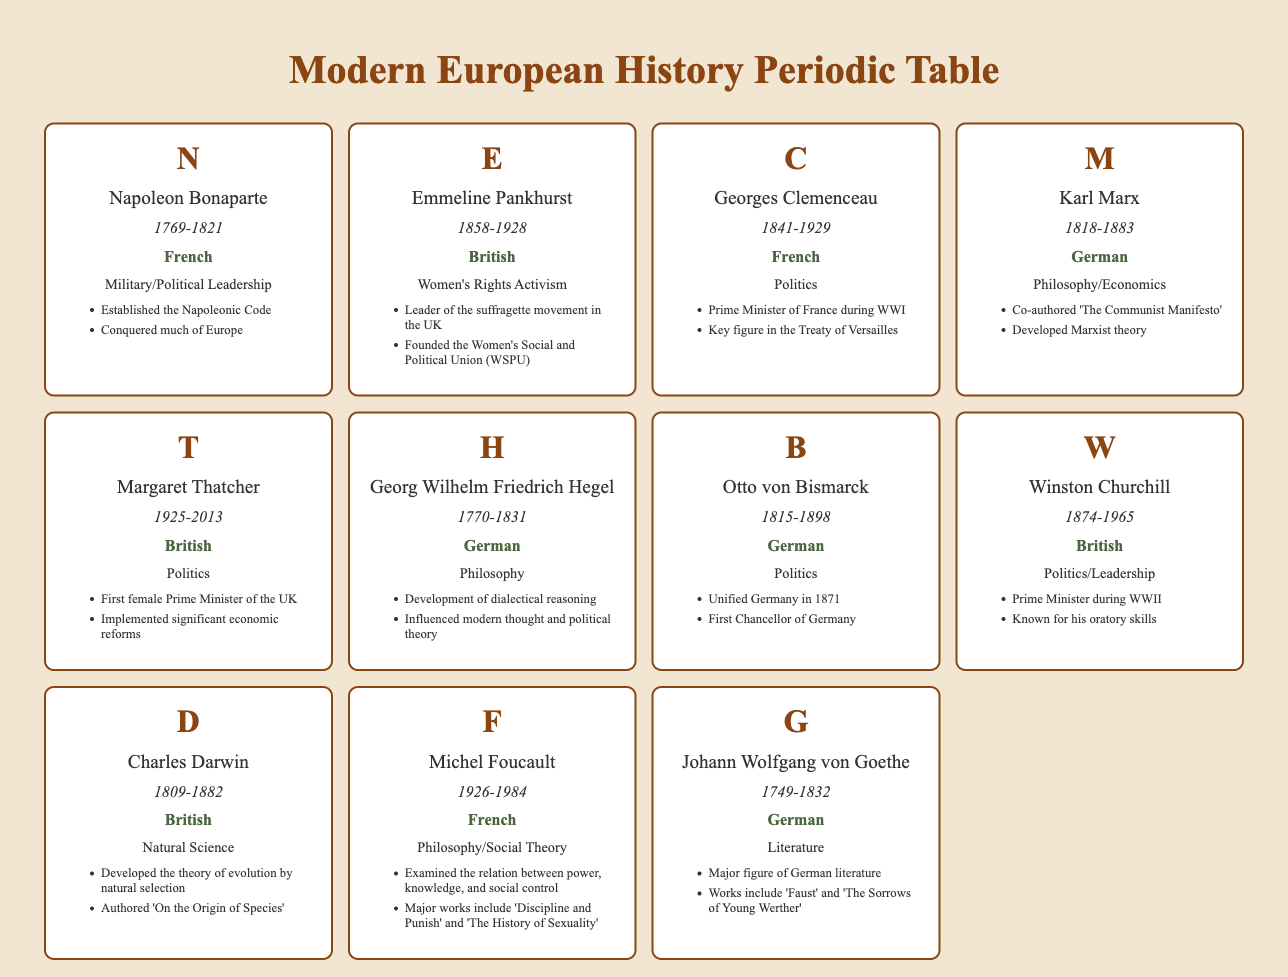What is the nationality of Emmeline Pankhurst? Emmeline Pankhurst is listed in the table under the nationality column, which states "British."
Answer: British Who was the Prime Minister of France during World War I? The table identifies Georges Clemenceau in the field of politics and lists his notable achievements, including being the "Prime Minister of France during WWI."
Answer: Georges Clemenceau How many historical figures in this table were born in the 19th century? The figures born in the 19th century, according to their birth years, are: Emmeline Pankhurst (1858), Georges Clemenceau (1841), Karl Marx (1818), Otto von Bismarck (1815), and Winston Churchill (1874). This counts to a total of 5 individuals.
Answer: 5 Did Napoleon Bonaparte establish the Napoleonic Code? The table directly lists one of Napoleon Bonaparte's notable achievements as "Established the Napoleonic Code," indicating the statement is true.
Answer: Yes Which historical figure has the earliest birth year listed in this table? By examining the birth years in the table, Napoleon Bonaparte was born in 1769, which is earlier than all other individuals listed in the table.
Answer: Napoleon Bonaparte What is the average birth year of the figures from Germany listed in this table? The German figures and their birth years are: Karl Marx (1818), Otto von Bismarck (1815), and Georg Wilhelm Friedrich Hegel (1770). Their total birth years sum up to 5303 (1818 + 1815 + 1770), and there are 3 figures. The average birth year is therefore 5303/3 = 1767.67, which rounds to 1768.
Answer: Approximately 1768 Who was the first female Prime Minister of the UK according to the table? The table lists Margaret Thatcher under the field of politics and notes her achievement as "First female Prime Minister of the UK."
Answer: Margaret Thatcher Did Karl Marx co-author 'The Communist Manifesto'? The table includes Karl Marx's notable achievements and clearly states he "Co-authored 'The Communist Manifesto'," confirming this fact is true.
Answer: Yes Which historical figure died in 1965? By checking the death years in the table, it is found that Winston Churchill died in 1965, as indicated in the corresponding section.
Answer: Winston Churchill 